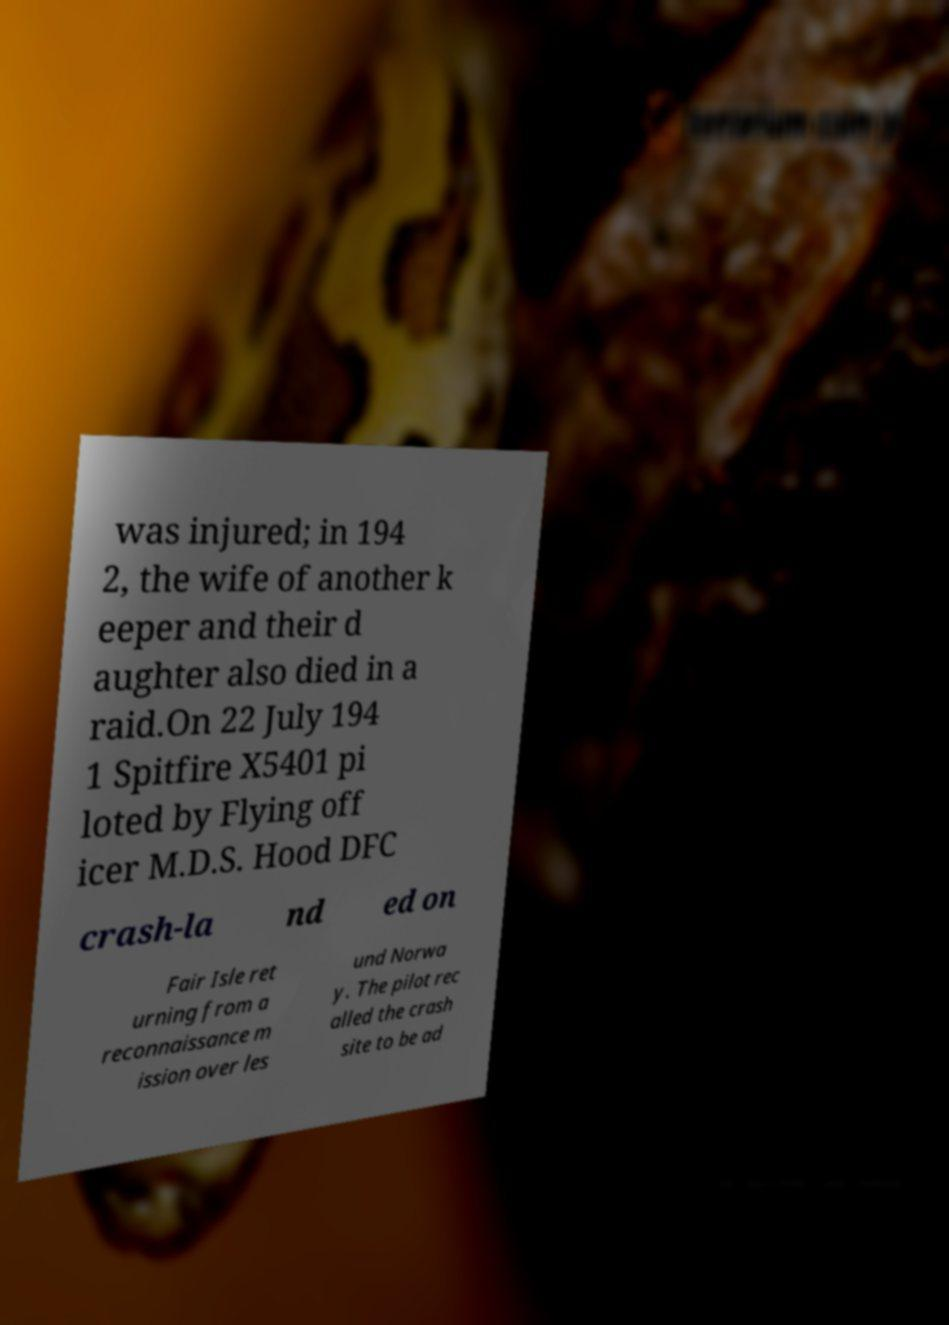What messages or text are displayed in this image? I need them in a readable, typed format. was injured; in 194 2, the wife of another k eeper and their d aughter also died in a raid.On 22 July 194 1 Spitfire X5401 pi loted by Flying off icer M.D.S. Hood DFC crash-la nd ed on Fair Isle ret urning from a reconnaissance m ission over les und Norwa y. The pilot rec alled the crash site to be ad 